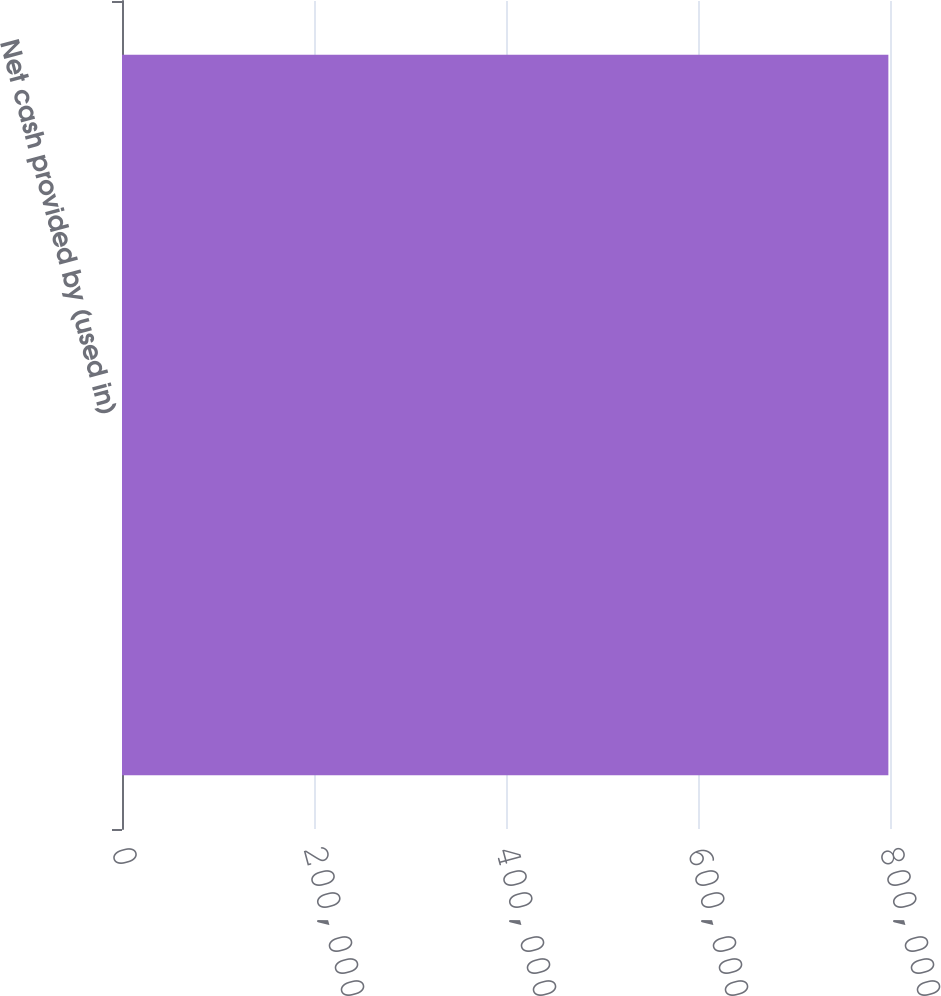<chart> <loc_0><loc_0><loc_500><loc_500><bar_chart><fcel>Net cash provided by (used in)<nl><fcel>798305<nl></chart> 